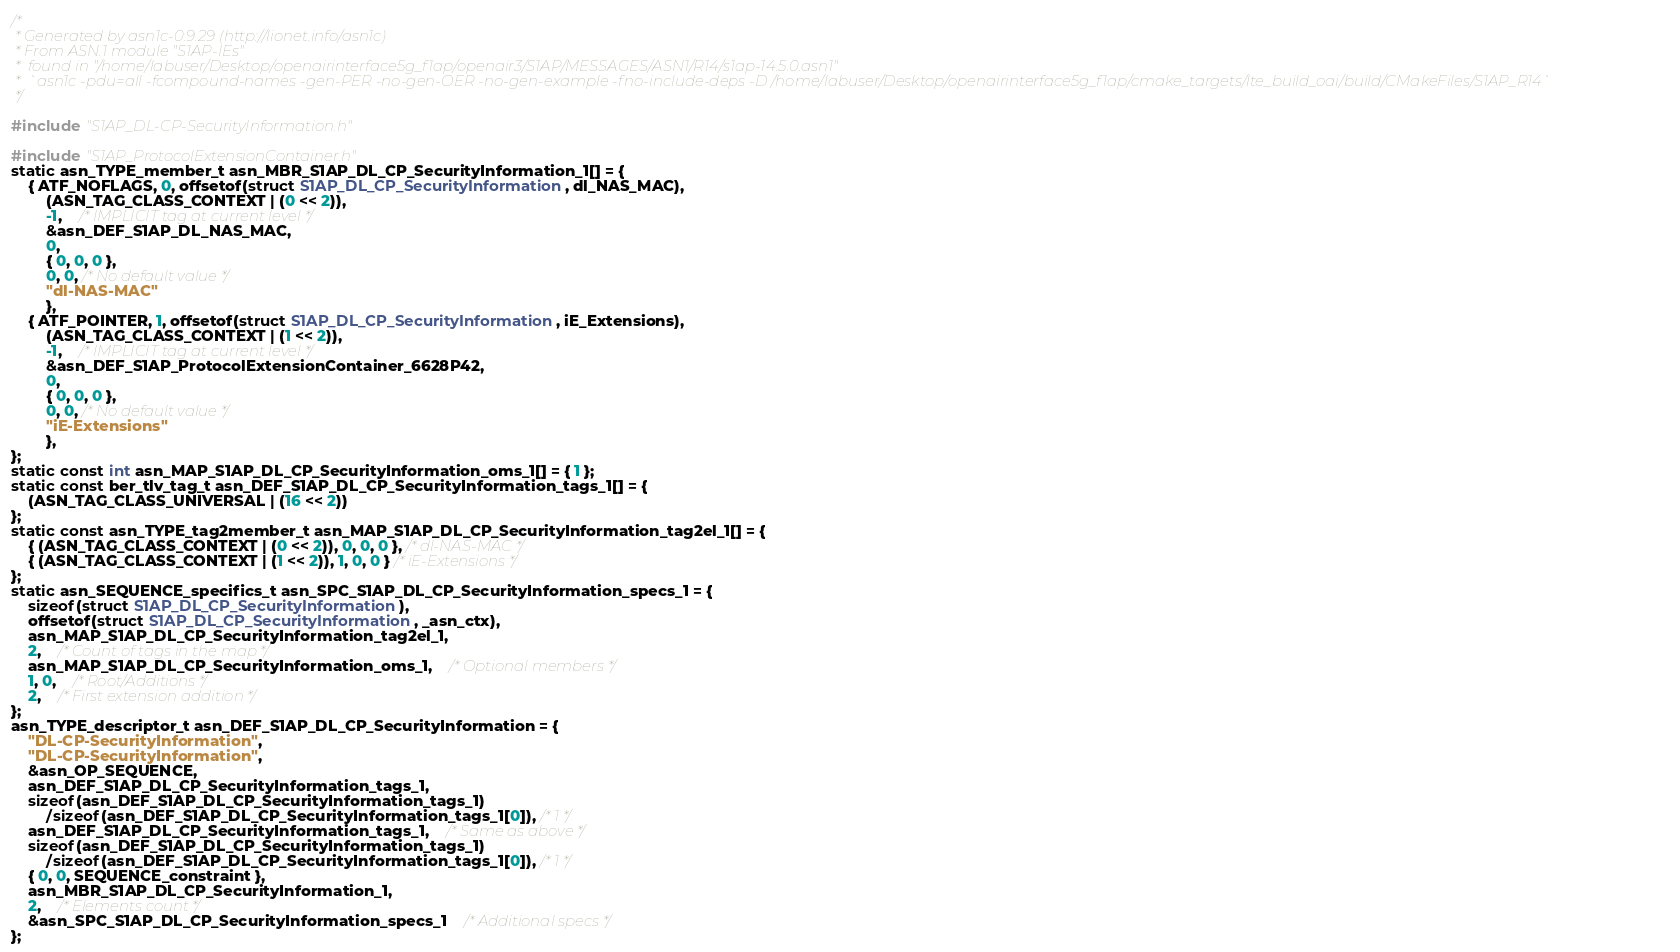<code> <loc_0><loc_0><loc_500><loc_500><_C_>/*
 * Generated by asn1c-0.9.29 (http://lionet.info/asn1c)
 * From ASN.1 module "S1AP-IEs"
 * 	found in "/home/labuser/Desktop/openairinterface5g_f1ap/openair3/S1AP/MESSAGES/ASN1/R14/s1ap-14.5.0.asn1"
 * 	`asn1c -pdu=all -fcompound-names -gen-PER -no-gen-OER -no-gen-example -fno-include-deps -D /home/labuser/Desktop/openairinterface5g_f1ap/cmake_targets/lte_build_oai/build/CMakeFiles/S1AP_R14`
 */

#include "S1AP_DL-CP-SecurityInformation.h"

#include "S1AP_ProtocolExtensionContainer.h"
static asn_TYPE_member_t asn_MBR_S1AP_DL_CP_SecurityInformation_1[] = {
	{ ATF_NOFLAGS, 0, offsetof(struct S1AP_DL_CP_SecurityInformation, dl_NAS_MAC),
		(ASN_TAG_CLASS_CONTEXT | (0 << 2)),
		-1,	/* IMPLICIT tag at current level */
		&asn_DEF_S1AP_DL_NAS_MAC,
		0,
		{ 0, 0, 0 },
		0, 0, /* No default value */
		"dl-NAS-MAC"
		},
	{ ATF_POINTER, 1, offsetof(struct S1AP_DL_CP_SecurityInformation, iE_Extensions),
		(ASN_TAG_CLASS_CONTEXT | (1 << 2)),
		-1,	/* IMPLICIT tag at current level */
		&asn_DEF_S1AP_ProtocolExtensionContainer_6628P42,
		0,
		{ 0, 0, 0 },
		0, 0, /* No default value */
		"iE-Extensions"
		},
};
static const int asn_MAP_S1AP_DL_CP_SecurityInformation_oms_1[] = { 1 };
static const ber_tlv_tag_t asn_DEF_S1AP_DL_CP_SecurityInformation_tags_1[] = {
	(ASN_TAG_CLASS_UNIVERSAL | (16 << 2))
};
static const asn_TYPE_tag2member_t asn_MAP_S1AP_DL_CP_SecurityInformation_tag2el_1[] = {
    { (ASN_TAG_CLASS_CONTEXT | (0 << 2)), 0, 0, 0 }, /* dl-NAS-MAC */
    { (ASN_TAG_CLASS_CONTEXT | (1 << 2)), 1, 0, 0 } /* iE-Extensions */
};
static asn_SEQUENCE_specifics_t asn_SPC_S1AP_DL_CP_SecurityInformation_specs_1 = {
	sizeof(struct S1AP_DL_CP_SecurityInformation),
	offsetof(struct S1AP_DL_CP_SecurityInformation, _asn_ctx),
	asn_MAP_S1AP_DL_CP_SecurityInformation_tag2el_1,
	2,	/* Count of tags in the map */
	asn_MAP_S1AP_DL_CP_SecurityInformation_oms_1,	/* Optional members */
	1, 0,	/* Root/Additions */
	2,	/* First extension addition */
};
asn_TYPE_descriptor_t asn_DEF_S1AP_DL_CP_SecurityInformation = {
	"DL-CP-SecurityInformation",
	"DL-CP-SecurityInformation",
	&asn_OP_SEQUENCE,
	asn_DEF_S1AP_DL_CP_SecurityInformation_tags_1,
	sizeof(asn_DEF_S1AP_DL_CP_SecurityInformation_tags_1)
		/sizeof(asn_DEF_S1AP_DL_CP_SecurityInformation_tags_1[0]), /* 1 */
	asn_DEF_S1AP_DL_CP_SecurityInformation_tags_1,	/* Same as above */
	sizeof(asn_DEF_S1AP_DL_CP_SecurityInformation_tags_1)
		/sizeof(asn_DEF_S1AP_DL_CP_SecurityInformation_tags_1[0]), /* 1 */
	{ 0, 0, SEQUENCE_constraint },
	asn_MBR_S1AP_DL_CP_SecurityInformation_1,
	2,	/* Elements count */
	&asn_SPC_S1AP_DL_CP_SecurityInformation_specs_1	/* Additional specs */
};

</code> 